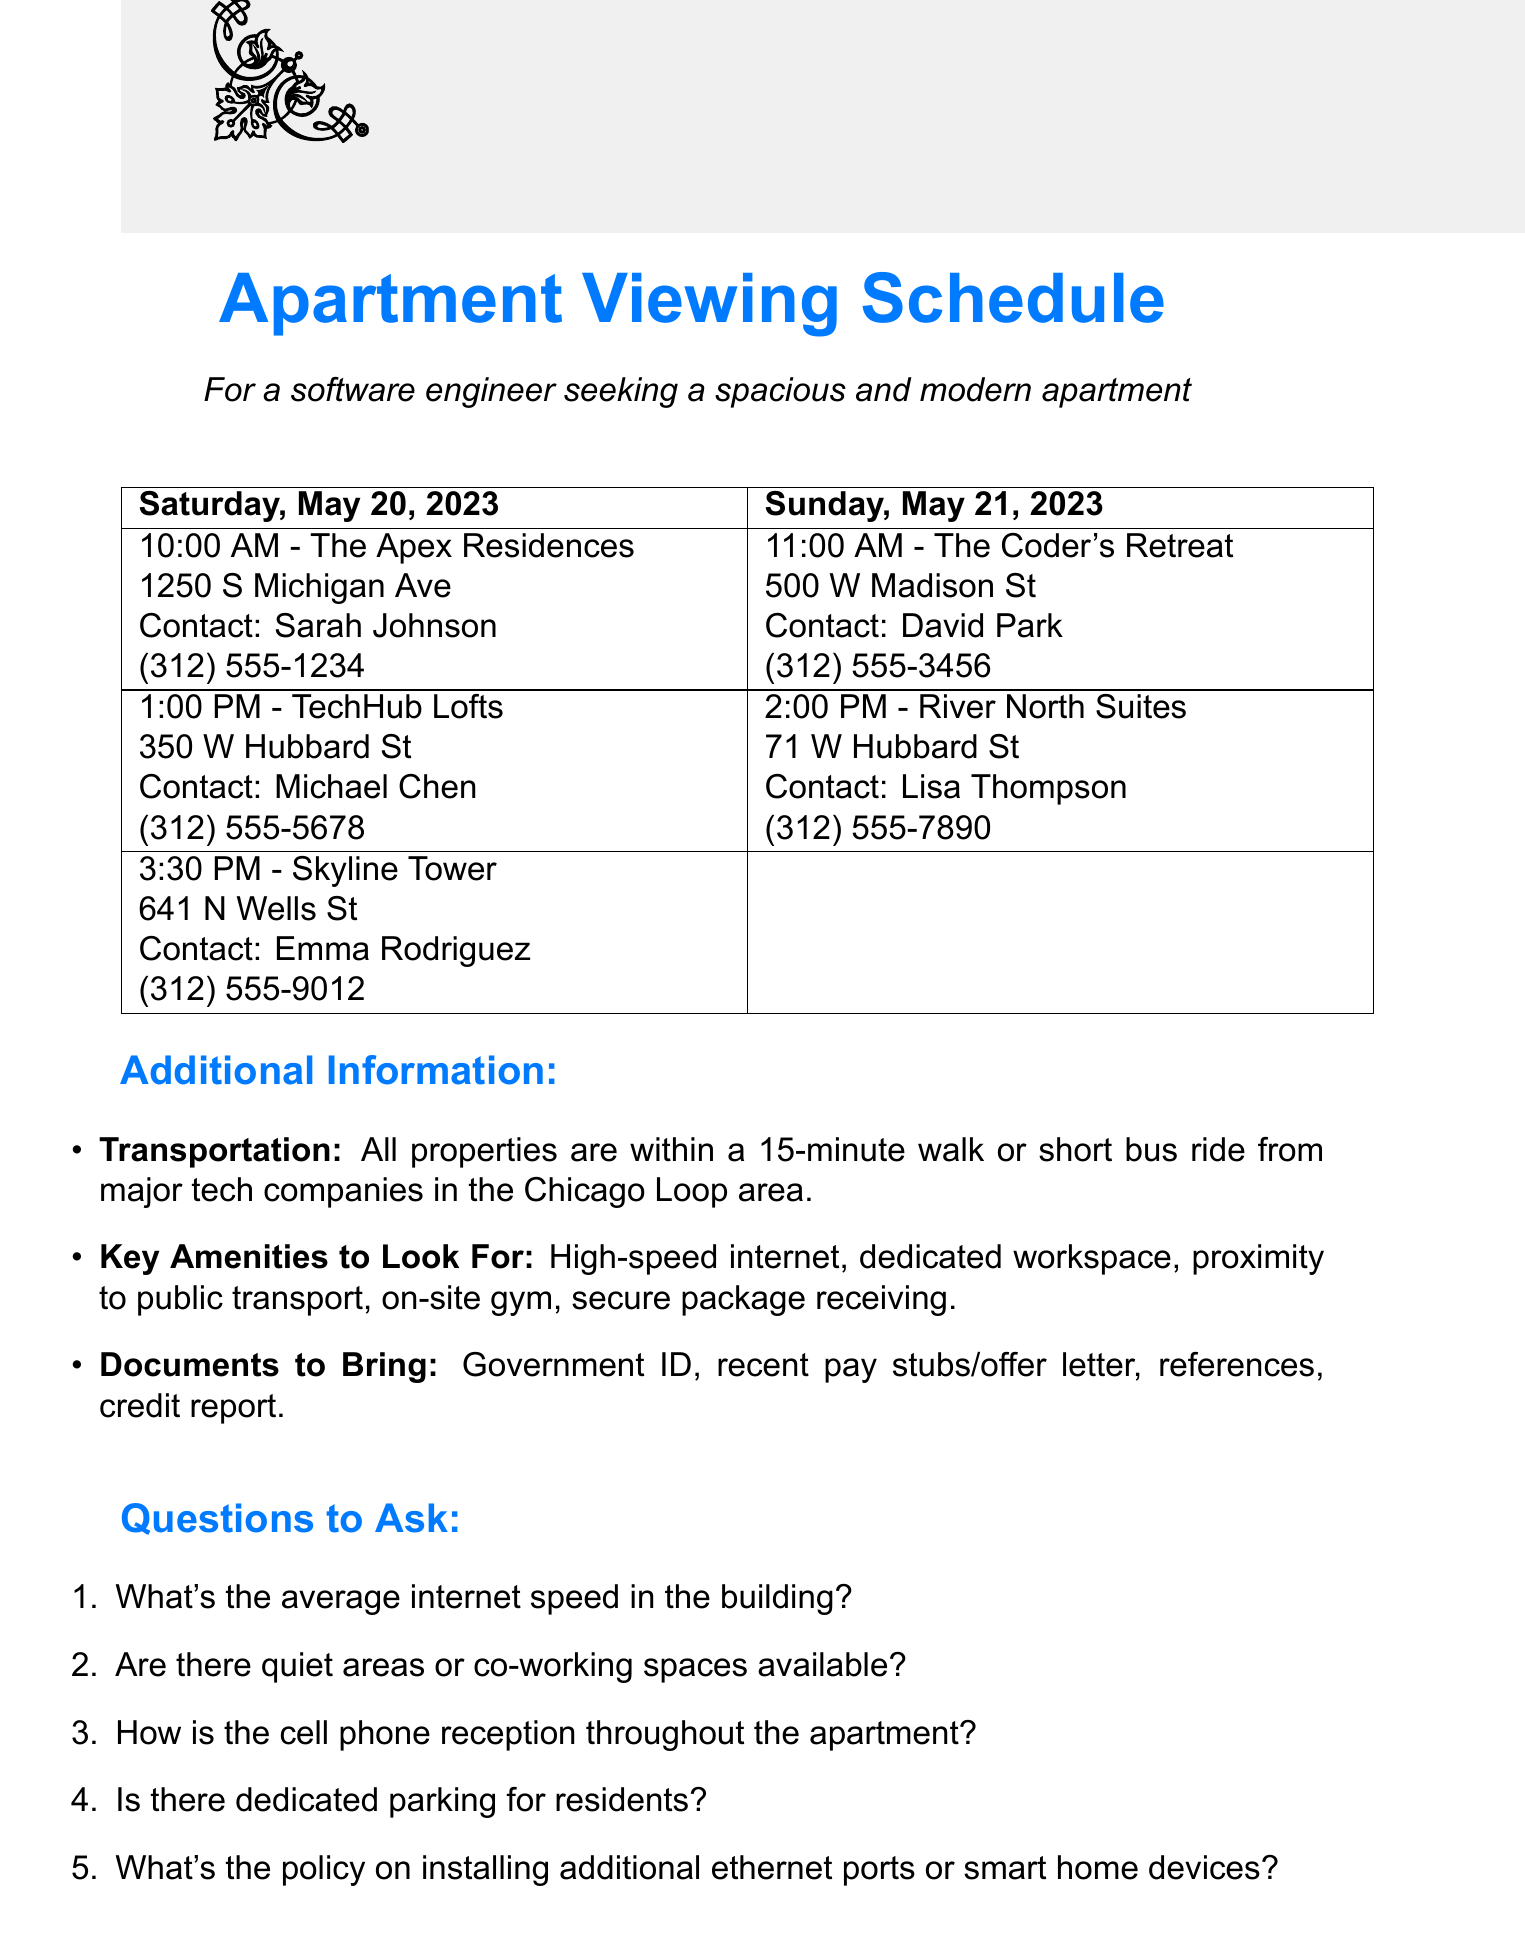What is the address of The Apex Residences? The address is specified in the document under the appointment details for The Apex Residences.
Answer: 1250 S Michigan Ave, Chicago, IL 60605 Who is the contact person for TechHub Lofts? The document provides the name of the contact person for TechHub Lofts in the appointment details.
Answer: Michael Chen What time is the viewing for Skyline Tower? The time for the Skyline Tower viewing is mentioned in the Saturday schedule of the document.
Answer: 3:30 PM What are the amenities to look for according to the document? The document lists several key amenities to look for, which can be found in the additional information section.
Answer: High-speed internet options, dedicated workspace or extra room for home office, proximity to public transportation, on-site gym or nearby fitness options, secure package receiving for tech deliveries What is the contact email for David Park? The contact email is stated in the document under the details for The Coder's Retreat appointment.
Answer: dpark@codersretreat.com Are all properties within walking distance of major tech companies? The document specifies a detail about transportation that can answer this question.
Answer: Yes How many appointments are scheduled for Sunday? The document outlines Sunday’s schedule and count of appointments.
Answer: 2 